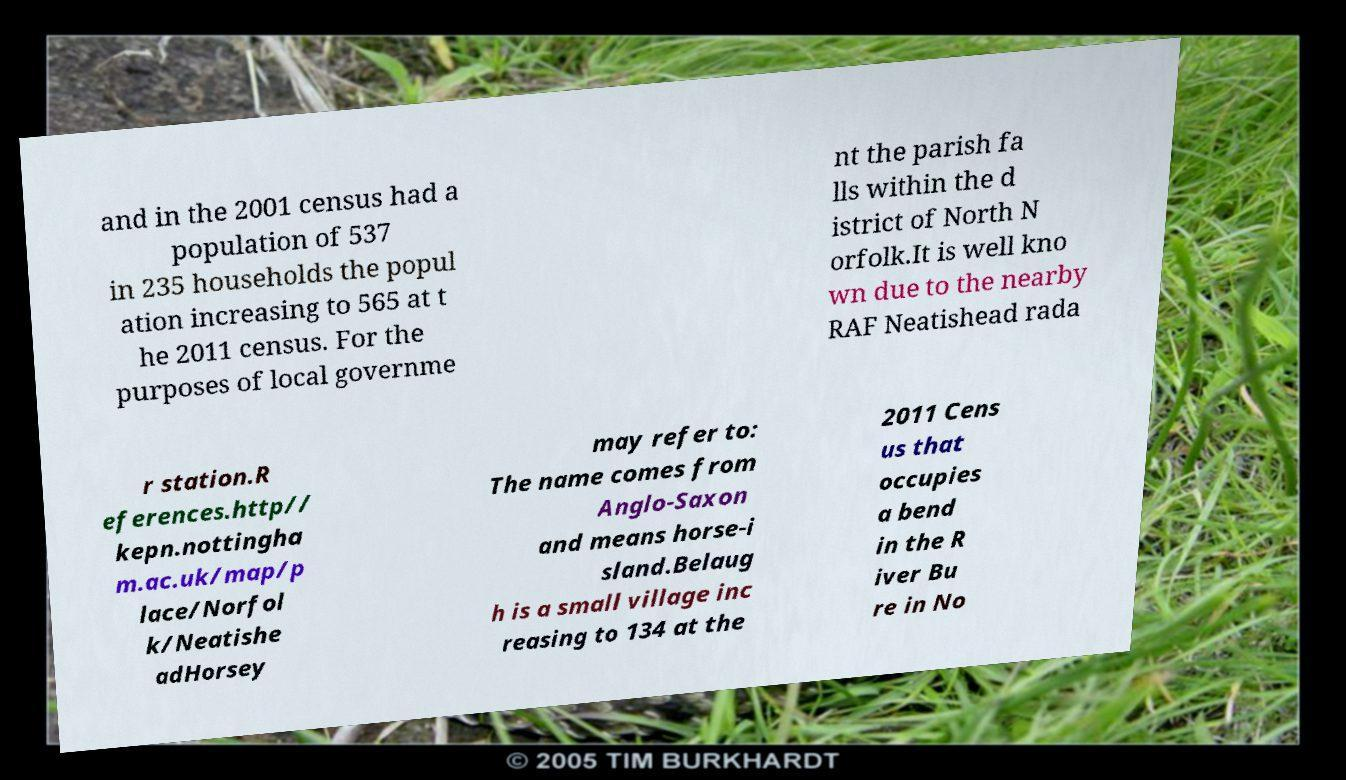What messages or text are displayed in this image? I need them in a readable, typed format. and in the 2001 census had a population of 537 in 235 households the popul ation increasing to 565 at t he 2011 census. For the purposes of local governme nt the parish fa lls within the d istrict of North N orfolk.It is well kno wn due to the nearby RAF Neatishead rada r station.R eferences.http// kepn.nottingha m.ac.uk/map/p lace/Norfol k/Neatishe adHorsey may refer to: The name comes from Anglo-Saxon and means horse-i sland.Belaug h is a small village inc reasing to 134 at the 2011 Cens us that occupies a bend in the R iver Bu re in No 